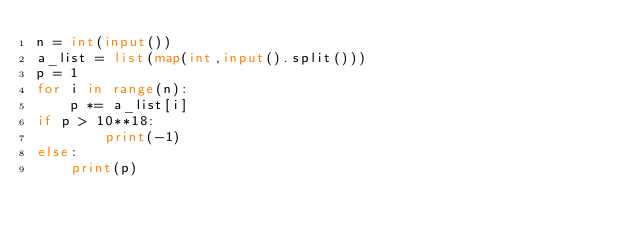Convert code to text. <code><loc_0><loc_0><loc_500><loc_500><_Python_>n = int(input())
a_list = list(map(int,input().split()))
p = 1
for i in range(n):
    p *= a_list[i]
if p > 10**18:
        print(-1)
else:
    print(p)
</code> 